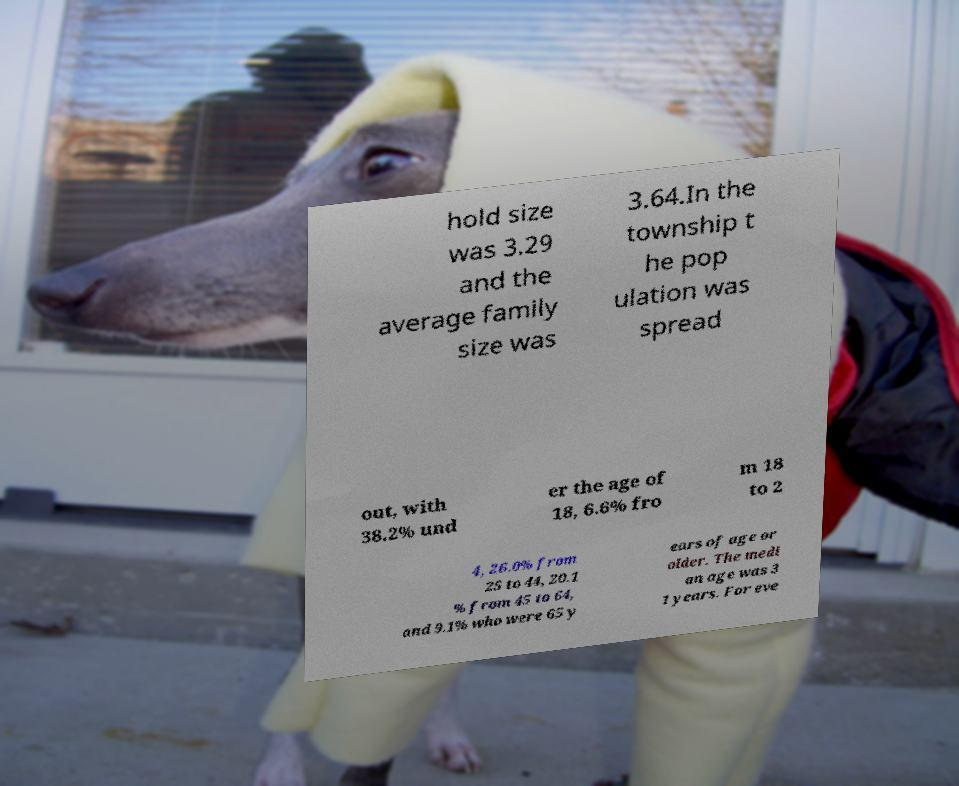For documentation purposes, I need the text within this image transcribed. Could you provide that? hold size was 3.29 and the average family size was 3.64.In the township t he pop ulation was spread out, with 38.2% und er the age of 18, 6.6% fro m 18 to 2 4, 26.0% from 25 to 44, 20.1 % from 45 to 64, and 9.1% who were 65 y ears of age or older. The medi an age was 3 1 years. For eve 